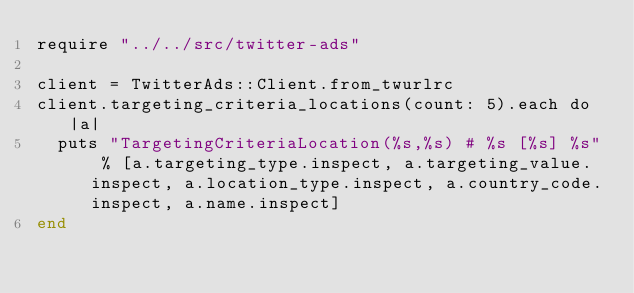<code> <loc_0><loc_0><loc_500><loc_500><_Crystal_>require "../../src/twitter-ads"

client = TwitterAds::Client.from_twurlrc
client.targeting_criteria_locations(count: 5).each do |a|
  puts "TargetingCriteriaLocation(%s,%s) # %s [%s] %s" % [a.targeting_type.inspect, a.targeting_value.inspect, a.location_type.inspect, a.country_code.inspect, a.name.inspect]
end
</code> 